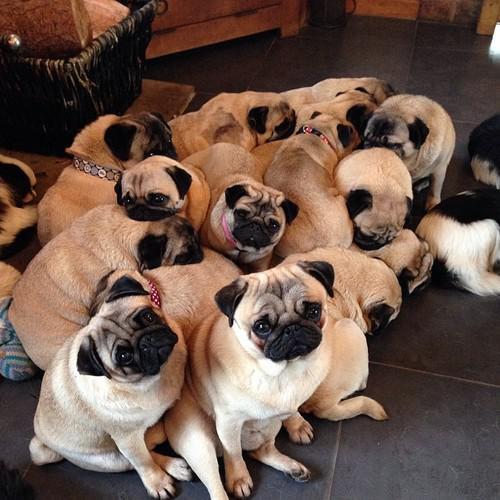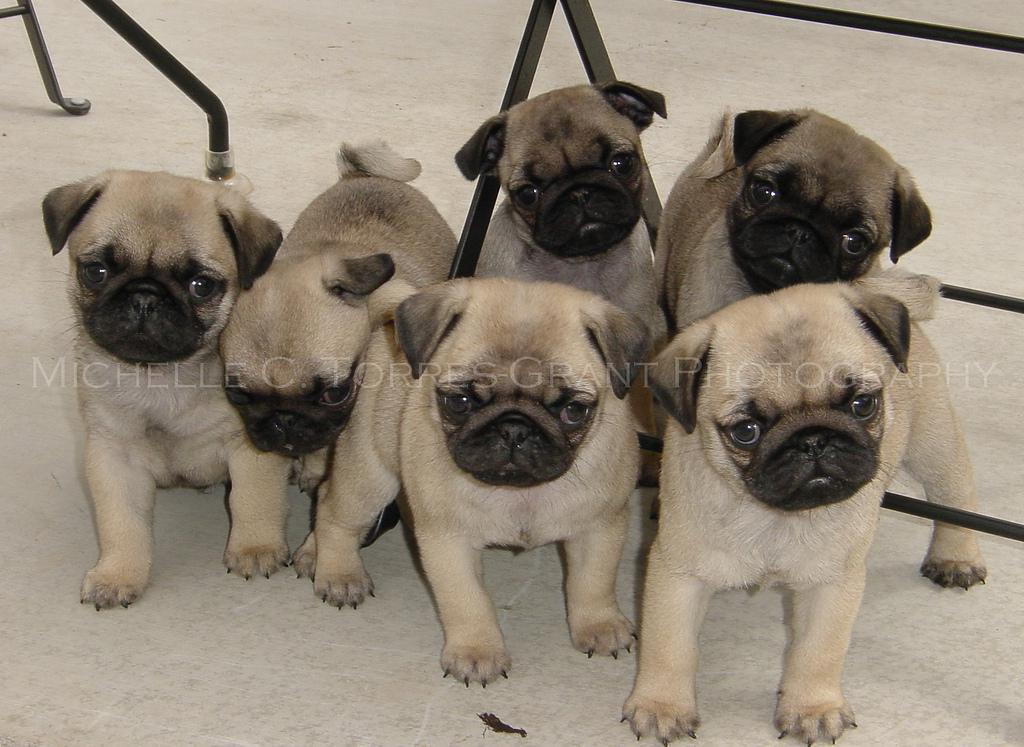The first image is the image on the left, the second image is the image on the right. Evaluate the accuracy of this statement regarding the images: "In one of the images, you will find only one dog.". Is it true? Answer yes or no. No. The first image is the image on the left, the second image is the image on the right. Considering the images on both sides, is "There are exactly six tan and black nosed pugs along side two predominately black dogs." valid? Answer yes or no. No. 